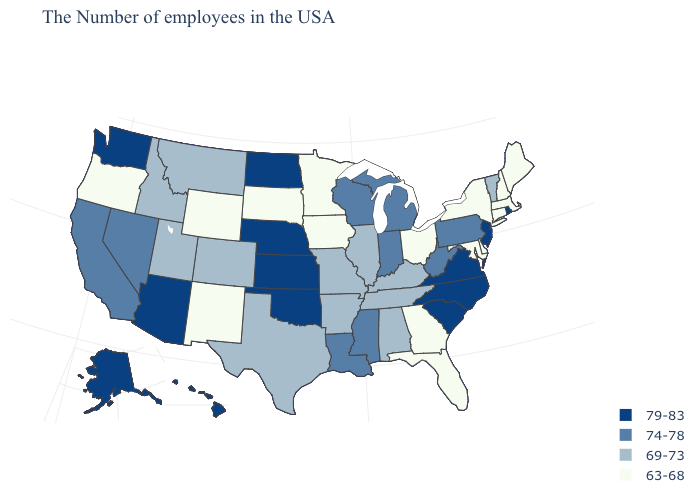Name the states that have a value in the range 74-78?
Give a very brief answer. Pennsylvania, West Virginia, Michigan, Indiana, Wisconsin, Mississippi, Louisiana, Nevada, California. What is the value of Minnesota?
Answer briefly. 63-68. Does Indiana have the highest value in the USA?
Quick response, please. No. Does the first symbol in the legend represent the smallest category?
Concise answer only. No. What is the highest value in the West ?
Be succinct. 79-83. Name the states that have a value in the range 63-68?
Short answer required. Maine, Massachusetts, New Hampshire, Connecticut, New York, Delaware, Maryland, Ohio, Florida, Georgia, Minnesota, Iowa, South Dakota, Wyoming, New Mexico, Oregon. Does Virginia have a higher value than New Jersey?
Answer briefly. No. Name the states that have a value in the range 79-83?
Short answer required. Rhode Island, New Jersey, Virginia, North Carolina, South Carolina, Kansas, Nebraska, Oklahoma, North Dakota, Arizona, Washington, Alaska, Hawaii. Among the states that border Illinois , does Iowa have the highest value?
Keep it brief. No. How many symbols are there in the legend?
Be succinct. 4. Is the legend a continuous bar?
Be succinct. No. What is the highest value in the USA?
Be succinct. 79-83. Name the states that have a value in the range 63-68?
Quick response, please. Maine, Massachusetts, New Hampshire, Connecticut, New York, Delaware, Maryland, Ohio, Florida, Georgia, Minnesota, Iowa, South Dakota, Wyoming, New Mexico, Oregon. What is the highest value in states that border New Jersey?
Answer briefly. 74-78. Name the states that have a value in the range 69-73?
Concise answer only. Vermont, Kentucky, Alabama, Tennessee, Illinois, Missouri, Arkansas, Texas, Colorado, Utah, Montana, Idaho. 